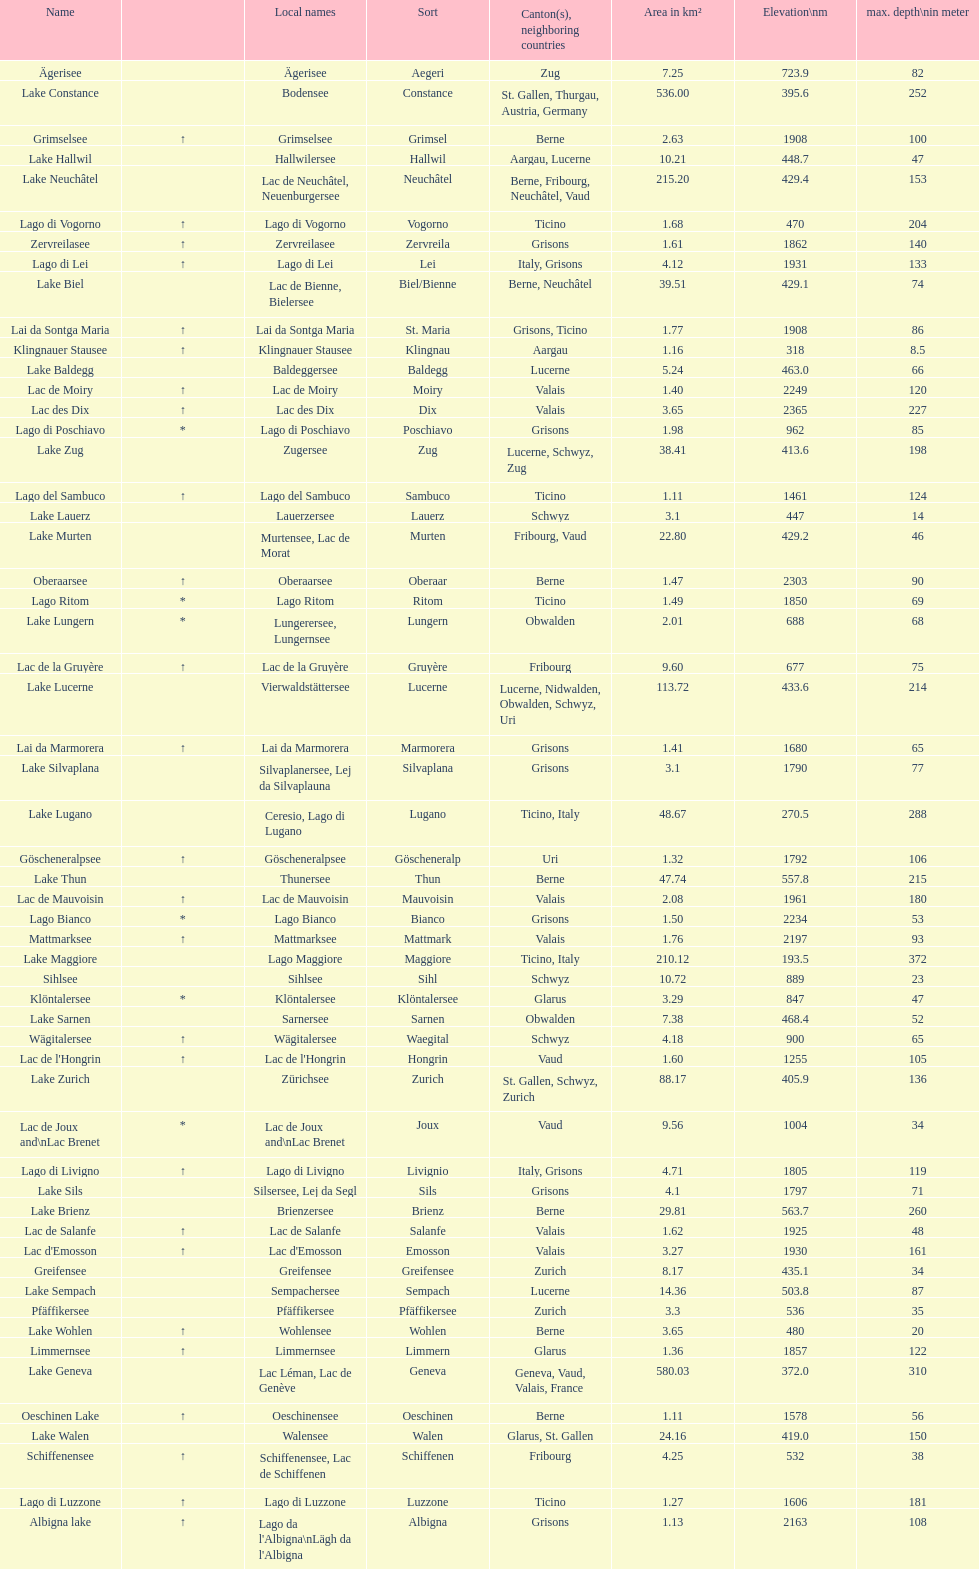Write the full table. {'header': ['Name', '', 'Local names', 'Sort', 'Canton(s), neighboring countries', 'Area in km²', 'Elevation\\nm', 'max. depth\\nin meter'], 'rows': [['Ägerisee', '', 'Ägerisee', 'Aegeri', 'Zug', '7.25', '723.9', '82'], ['Lake Constance', '', 'Bodensee', 'Constance', 'St. Gallen, Thurgau, Austria, Germany', '536.00', '395.6', '252'], ['Grimselsee', '↑', 'Grimselsee', 'Grimsel', 'Berne', '2.63', '1908', '100'], ['Lake Hallwil', '', 'Hallwilersee', 'Hallwil', 'Aargau, Lucerne', '10.21', '448.7', '47'], ['Lake Neuchâtel', '', 'Lac de Neuchâtel, Neuenburgersee', 'Neuchâtel', 'Berne, Fribourg, Neuchâtel, Vaud', '215.20', '429.4', '153'], ['Lago di Vogorno', '↑', 'Lago di Vogorno', 'Vogorno', 'Ticino', '1.68', '470', '204'], ['Zervreilasee', '↑', 'Zervreilasee', 'Zervreila', 'Grisons', '1.61', '1862', '140'], ['Lago di Lei', '↑', 'Lago di Lei', 'Lei', 'Italy, Grisons', '4.12', '1931', '133'], ['Lake Biel', '', 'Lac de Bienne, Bielersee', 'Biel/Bienne', 'Berne, Neuchâtel', '39.51', '429.1', '74'], ['Lai da Sontga Maria', '↑', 'Lai da Sontga Maria', 'St. Maria', 'Grisons, Ticino', '1.77', '1908', '86'], ['Klingnauer Stausee', '↑', 'Klingnauer Stausee', 'Klingnau', 'Aargau', '1.16', '318', '8.5'], ['Lake Baldegg', '', 'Baldeggersee', 'Baldegg', 'Lucerne', '5.24', '463.0', '66'], ['Lac de Moiry', '↑', 'Lac de Moiry', 'Moiry', 'Valais', '1.40', '2249', '120'], ['Lac des Dix', '↑', 'Lac des Dix', 'Dix', 'Valais', '3.65', '2365', '227'], ['Lago di Poschiavo', '*', 'Lago di Poschiavo', 'Poschiavo', 'Grisons', '1.98', '962', '85'], ['Lake Zug', '', 'Zugersee', 'Zug', 'Lucerne, Schwyz, Zug', '38.41', '413.6', '198'], ['Lago del Sambuco', '↑', 'Lago del Sambuco', 'Sambuco', 'Ticino', '1.11', '1461', '124'], ['Lake Lauerz', '', 'Lauerzersee', 'Lauerz', 'Schwyz', '3.1', '447', '14'], ['Lake Murten', '', 'Murtensee, Lac de Morat', 'Murten', 'Fribourg, Vaud', '22.80', '429.2', '46'], ['Oberaarsee', '↑', 'Oberaarsee', 'Oberaar', 'Berne', '1.47', '2303', '90'], ['Lago Ritom', '*', 'Lago Ritom', 'Ritom', 'Ticino', '1.49', '1850', '69'], ['Lake Lungern', '*', 'Lungerersee, Lungernsee', 'Lungern', 'Obwalden', '2.01', '688', '68'], ['Lac de la Gruyère', '↑', 'Lac de la Gruyère', 'Gruyère', 'Fribourg', '9.60', '677', '75'], ['Lake Lucerne', '', 'Vierwaldstättersee', 'Lucerne', 'Lucerne, Nidwalden, Obwalden, Schwyz, Uri', '113.72', '433.6', '214'], ['Lai da Marmorera', '↑', 'Lai da Marmorera', 'Marmorera', 'Grisons', '1.41', '1680', '65'], ['Lake Silvaplana', '', 'Silvaplanersee, Lej da Silvaplauna', 'Silvaplana', 'Grisons', '3.1', '1790', '77'], ['Lake Lugano', '', 'Ceresio, Lago di Lugano', 'Lugano', 'Ticino, Italy', '48.67', '270.5', '288'], ['Göscheneralpsee', '↑', 'Göscheneralpsee', 'Göscheneralp', 'Uri', '1.32', '1792', '106'], ['Lake Thun', '', 'Thunersee', 'Thun', 'Berne', '47.74', '557.8', '215'], ['Lac de Mauvoisin', '↑', 'Lac de Mauvoisin', 'Mauvoisin', 'Valais', '2.08', '1961', '180'], ['Lago Bianco', '*', 'Lago Bianco', 'Bianco', 'Grisons', '1.50', '2234', '53'], ['Mattmarksee', '↑', 'Mattmarksee', 'Mattmark', 'Valais', '1.76', '2197', '93'], ['Lake Maggiore', '', 'Lago Maggiore', 'Maggiore', 'Ticino, Italy', '210.12', '193.5', '372'], ['Sihlsee', '', 'Sihlsee', 'Sihl', 'Schwyz', '10.72', '889', '23'], ['Klöntalersee', '*', 'Klöntalersee', 'Klöntalersee', 'Glarus', '3.29', '847', '47'], ['Lake Sarnen', '', 'Sarnersee', 'Sarnen', 'Obwalden', '7.38', '468.4', '52'], ['Wägitalersee', '↑', 'Wägitalersee', 'Waegital', 'Schwyz', '4.18', '900', '65'], ["Lac de l'Hongrin", '↑', "Lac de l'Hongrin", 'Hongrin', 'Vaud', '1.60', '1255', '105'], ['Lake Zurich', '', 'Zürichsee', 'Zurich', 'St. Gallen, Schwyz, Zurich', '88.17', '405.9', '136'], ['Lac de Joux and\\nLac Brenet', '*', 'Lac de Joux and\\nLac Brenet', 'Joux', 'Vaud', '9.56', '1004', '34'], ['Lago di Livigno', '↑', 'Lago di Livigno', 'Livignio', 'Italy, Grisons', '4.71', '1805', '119'], ['Lake Sils', '', 'Silsersee, Lej da Segl', 'Sils', 'Grisons', '4.1', '1797', '71'], ['Lake Brienz', '', 'Brienzersee', 'Brienz', 'Berne', '29.81', '563.7', '260'], ['Lac de Salanfe', '↑', 'Lac de Salanfe', 'Salanfe', 'Valais', '1.62', '1925', '48'], ["Lac d'Emosson", '↑', "Lac d'Emosson", 'Emosson', 'Valais', '3.27', '1930', '161'], ['Greifensee', '', 'Greifensee', 'Greifensee', 'Zurich', '8.17', '435.1', '34'], ['Lake Sempach', '', 'Sempachersee', 'Sempach', 'Lucerne', '14.36', '503.8', '87'], ['Pfäffikersee', '', 'Pfäffikersee', 'Pfäffikersee', 'Zurich', '3.3', '536', '35'], ['Lake Wohlen', '↑', 'Wohlensee', 'Wohlen', 'Berne', '3.65', '480', '20'], ['Limmernsee', '↑', 'Limmernsee', 'Limmern', 'Glarus', '1.36', '1857', '122'], ['Lake Geneva', '', 'Lac Léman, Lac de Genève', 'Geneva', 'Geneva, Vaud, Valais, France', '580.03', '372.0', '310'], ['Oeschinen Lake', '↑', 'Oeschinensee', 'Oeschinen', 'Berne', '1.11', '1578', '56'], ['Lake Walen', '', 'Walensee', 'Walen', 'Glarus, St. Gallen', '24.16', '419.0', '150'], ['Schiffenensee', '↑', 'Schiffenensee, Lac de Schiffenen', 'Schiffenen', 'Fribourg', '4.25', '532', '38'], ['Lago di Luzzone', '↑', 'Lago di Luzzone', 'Luzzone', 'Ticino', '1.27', '1606', '181'], ['Albigna lake', '↑', "Lago da l'Albigna\\nLägh da l'Albigna", 'Albigna', 'Grisons', '1.13', '2163', '108']]} What is the total area in km² of lake sils? 4.1. 